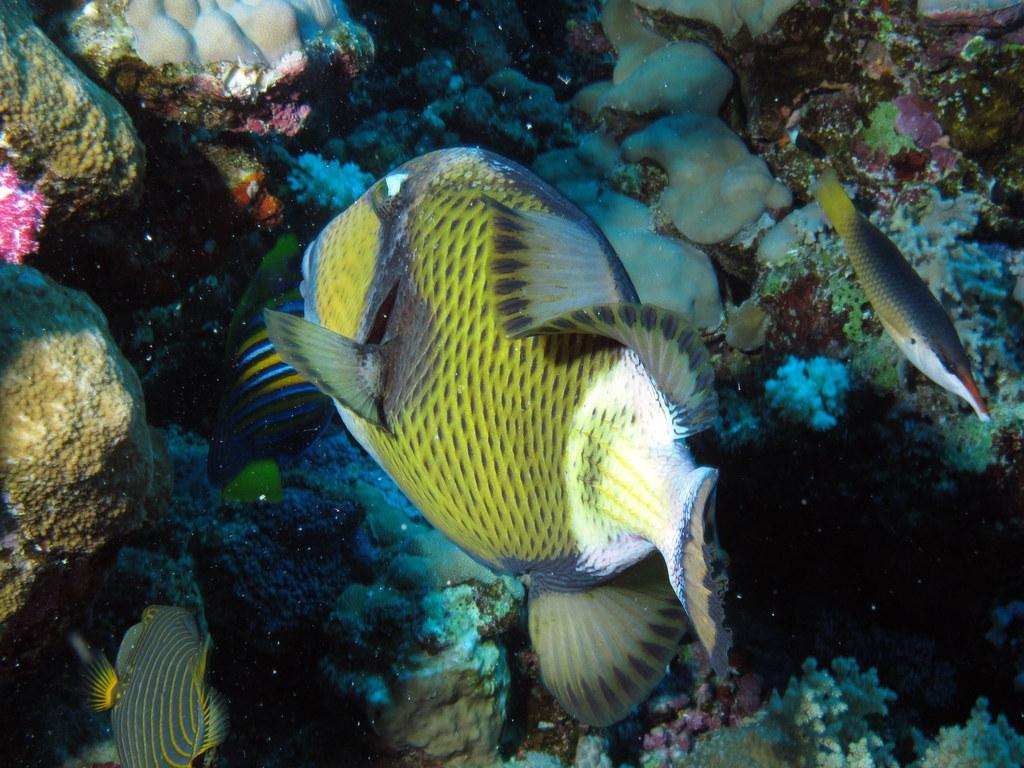What type of natural feature is present in the image? The image contains a water body. What type of aquatic animals can be seen in the water body? There are fish in the water body. What other elements can be seen in the image besides the water body? There are rocks and moss in the image. What is the value of the gold nugget in the image? There is no gold nugget present in the image. What color is the sky in the image? The provided facts do not mention the sky, so we cannot determine its color from the image. 